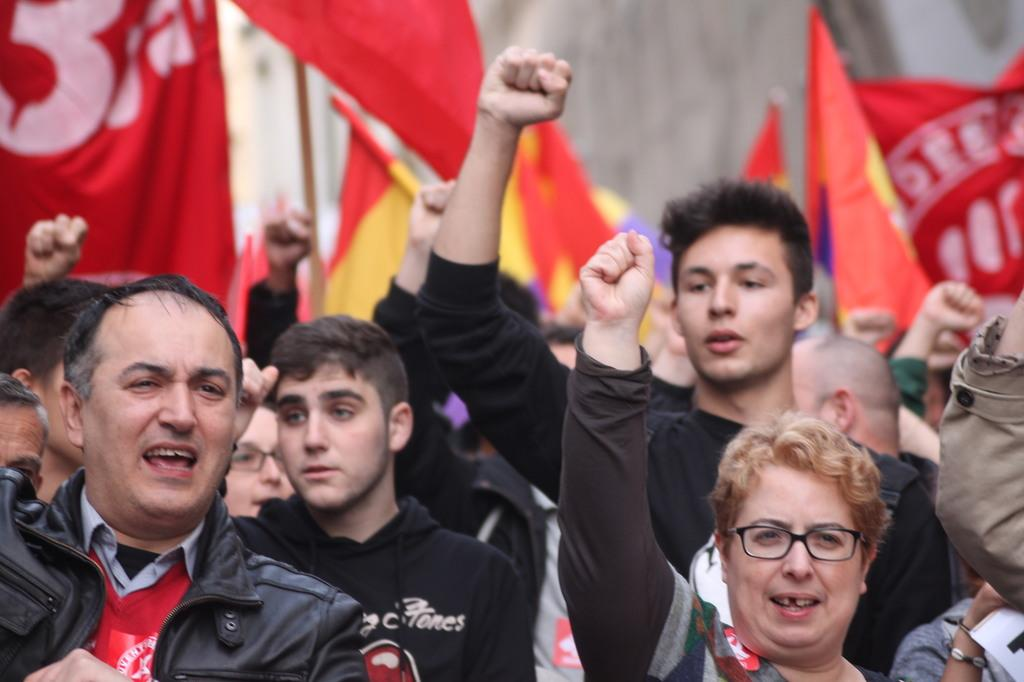What is happening with the group of people in the image? The people in the image are raising their hands and shouting. What can be seen in the background of the image? There are red color flags in the background of the image. Can you see a river flowing near the group of people in the image? There is no river visible in the image. Is there a horse present among the group of people in the people in the image? There is no horse present in the image. 